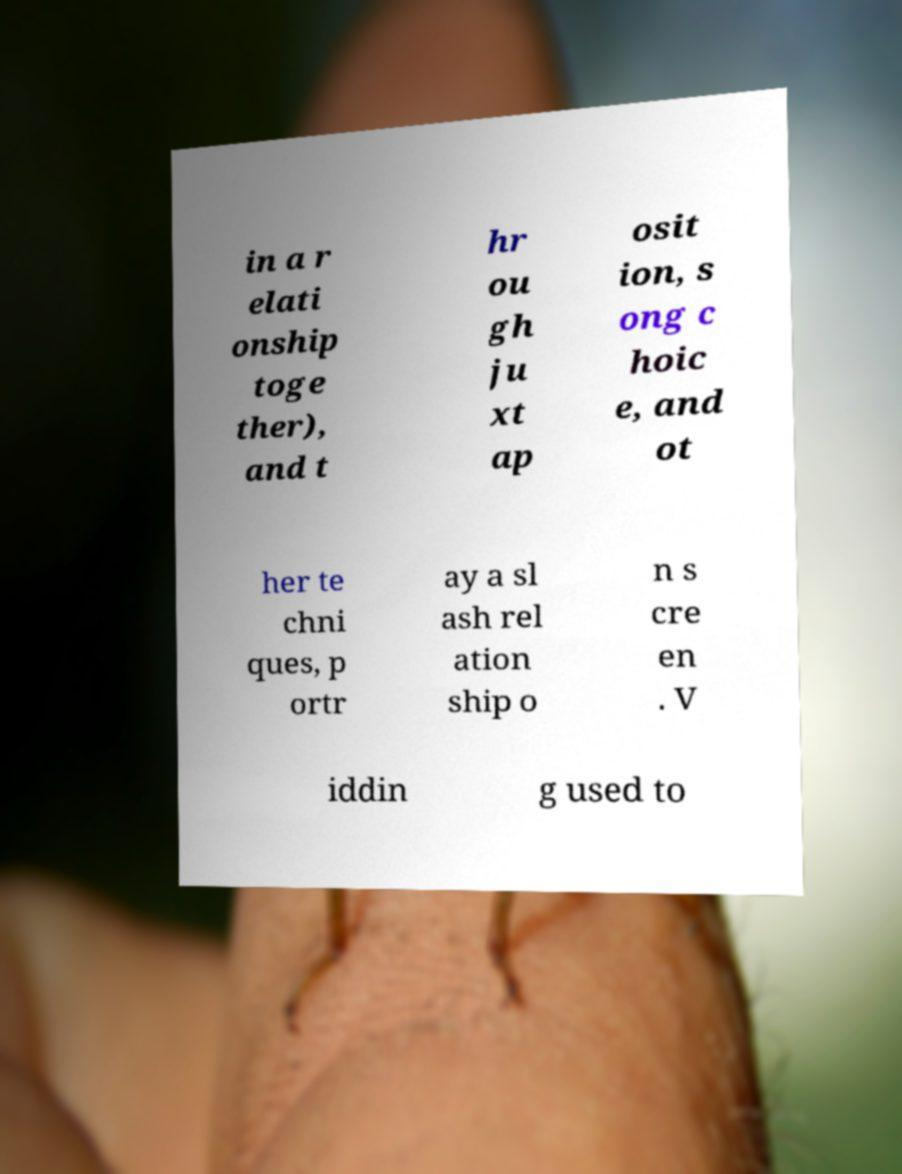Can you read and provide the text displayed in the image?This photo seems to have some interesting text. Can you extract and type it out for me? in a r elati onship toge ther), and t hr ou gh ju xt ap osit ion, s ong c hoic e, and ot her te chni ques, p ortr ay a sl ash rel ation ship o n s cre en . V iddin g used to 